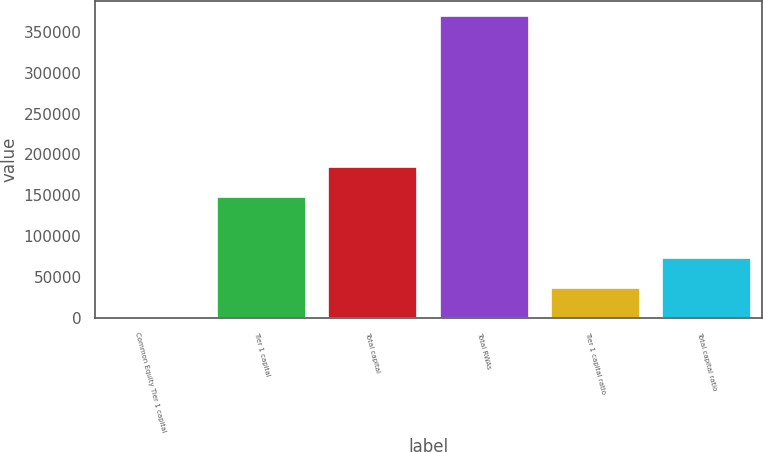Convert chart to OTSL. <chart><loc_0><loc_0><loc_500><loc_500><bar_chart><fcel>Common Equity Tier 1 capital<fcel>Tier 1 capital<fcel>Total capital<fcel>Total RWAs<fcel>Tier 1 capital ratio<fcel>Total capital ratio<nl><fcel>16.5<fcel>147841<fcel>184797<fcel>369578<fcel>36972.7<fcel>73928.8<nl></chart> 